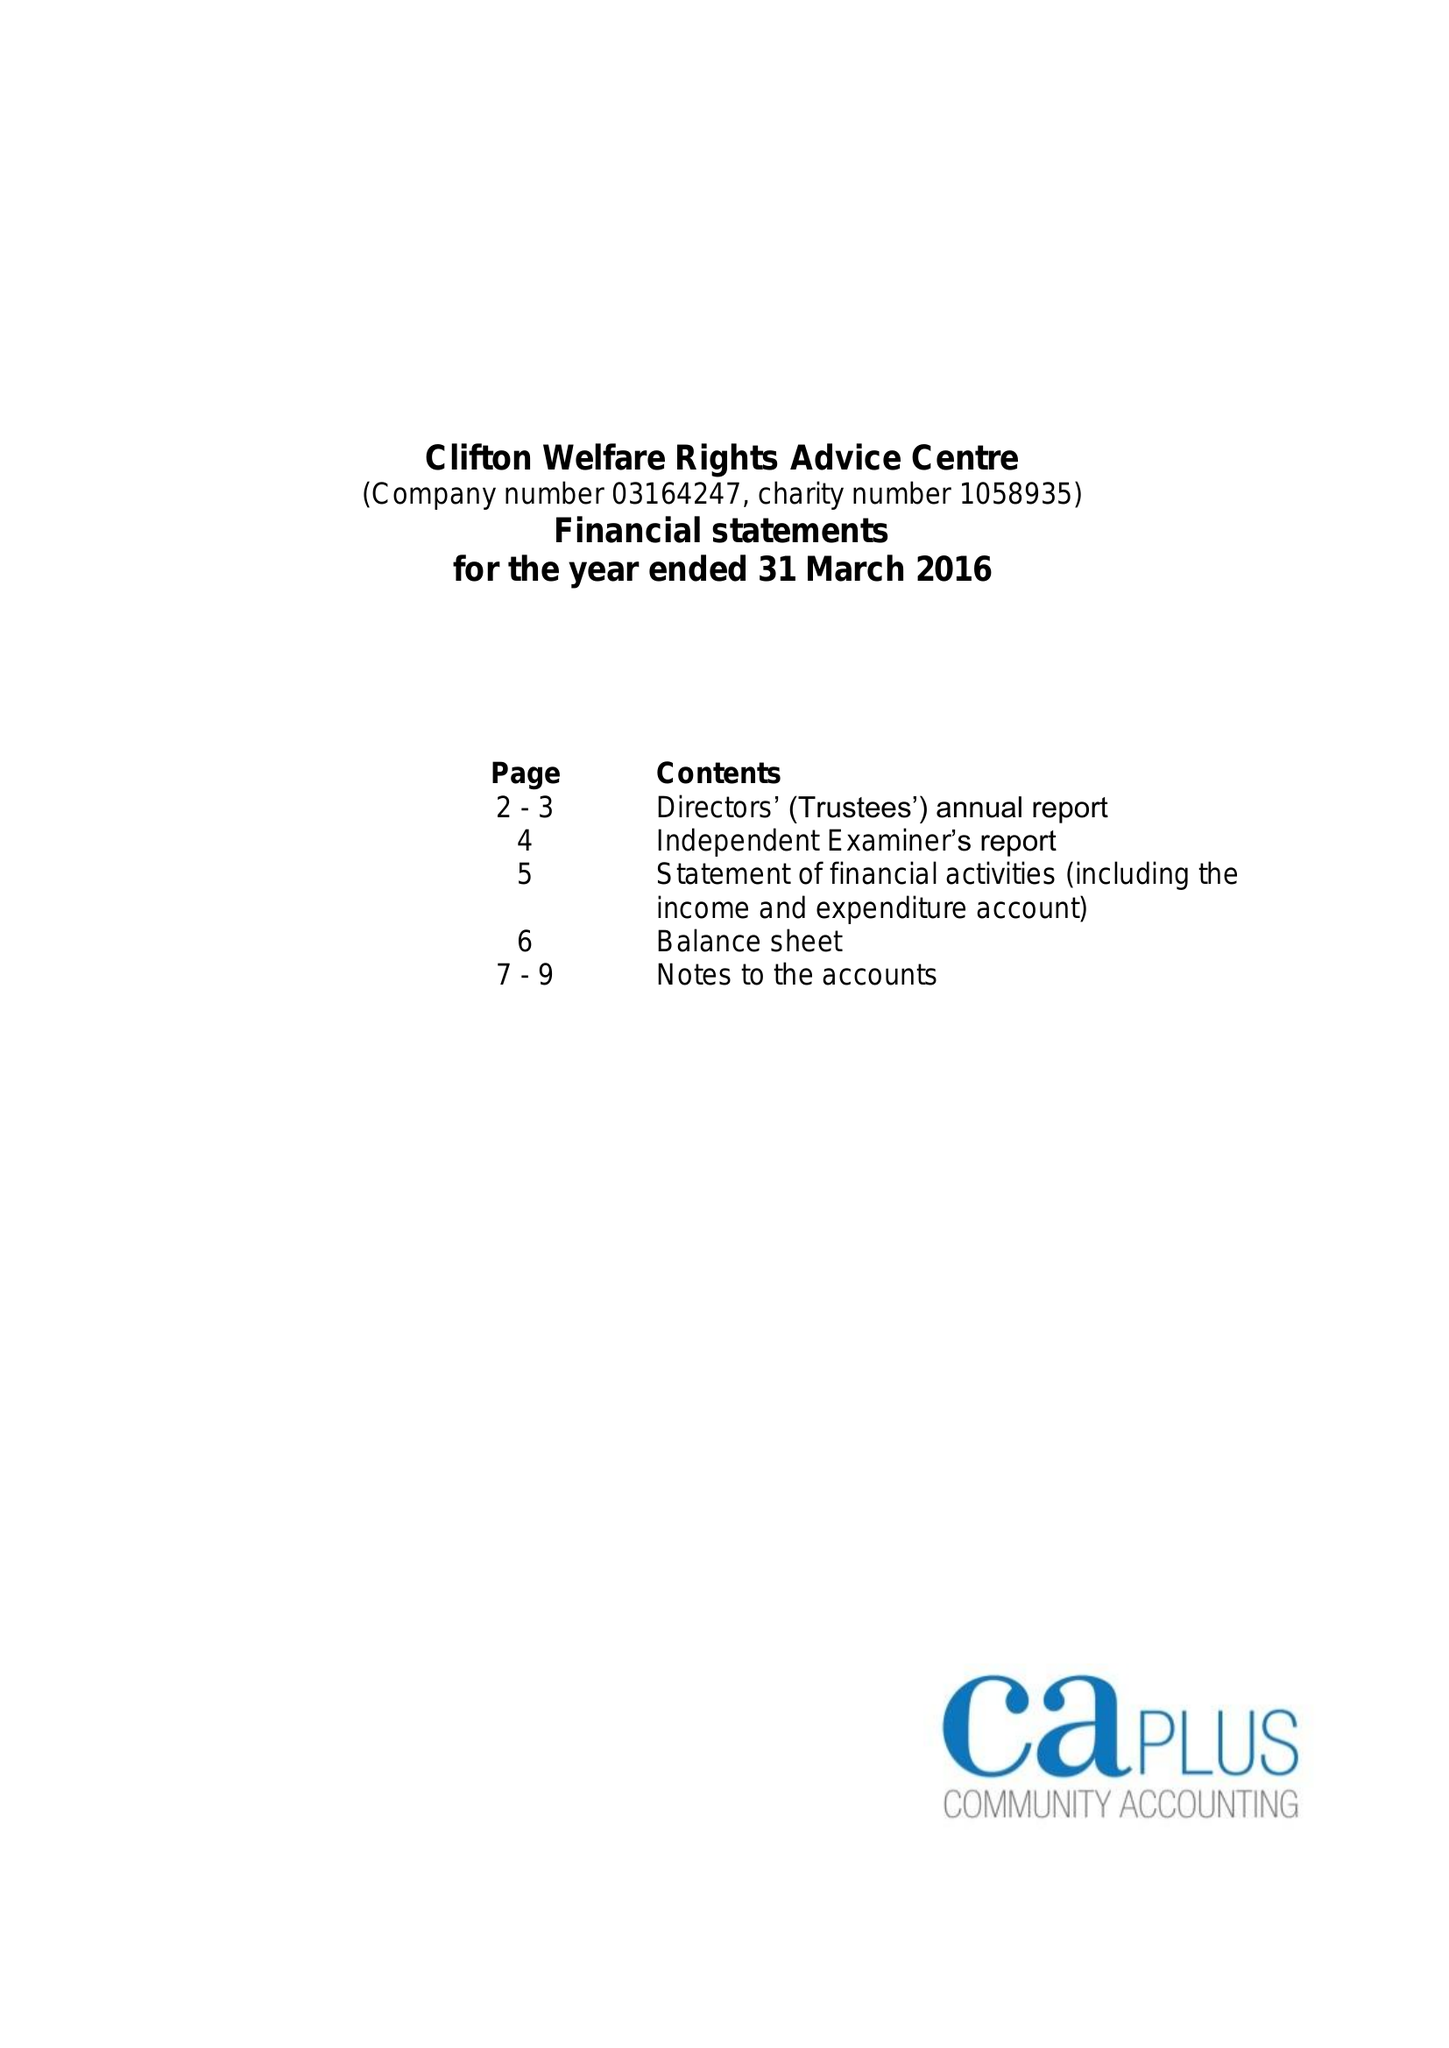What is the value for the income_annually_in_british_pounds?
Answer the question using a single word or phrase. 86605.00 